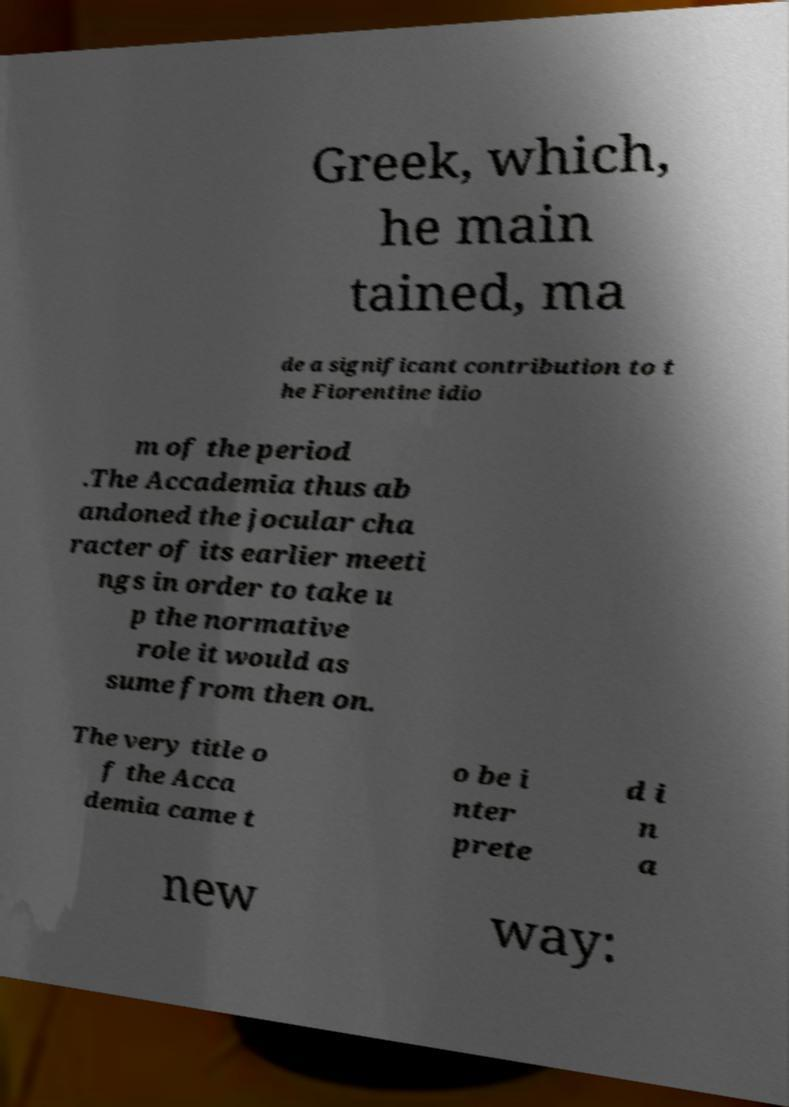For documentation purposes, I need the text within this image transcribed. Could you provide that? Greek, which, he main tained, ma de a significant contribution to t he Fiorentine idio m of the period .The Accademia thus ab andoned the jocular cha racter of its earlier meeti ngs in order to take u p the normative role it would as sume from then on. The very title o f the Acca demia came t o be i nter prete d i n a new way: 